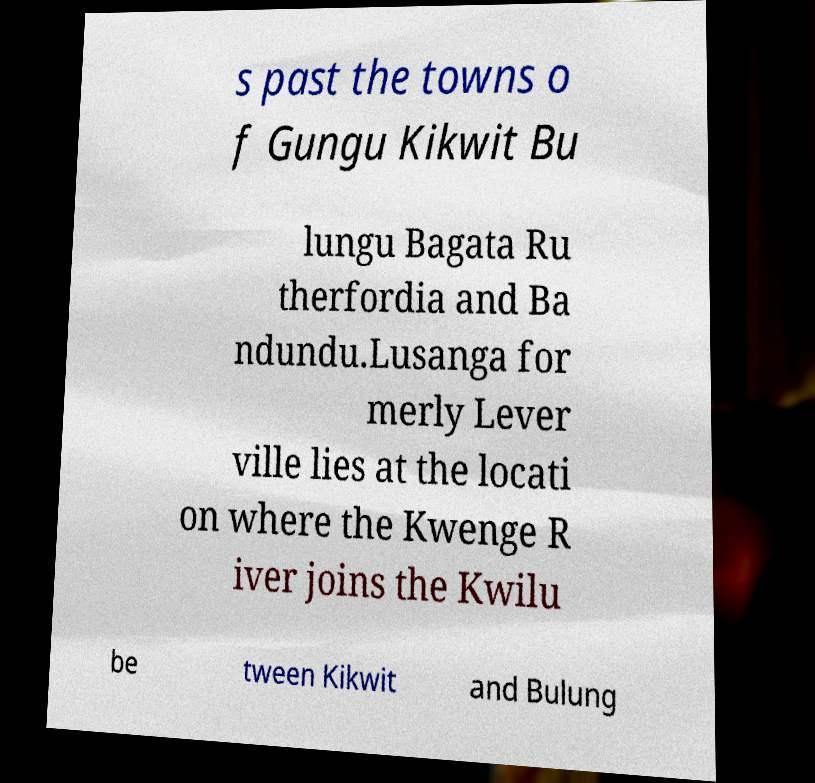Please identify and transcribe the text found in this image. s past the towns o f Gungu Kikwit Bu lungu Bagata Ru therfordia and Ba ndundu.Lusanga for merly Lever ville lies at the locati on where the Kwenge R iver joins the Kwilu be tween Kikwit and Bulung 